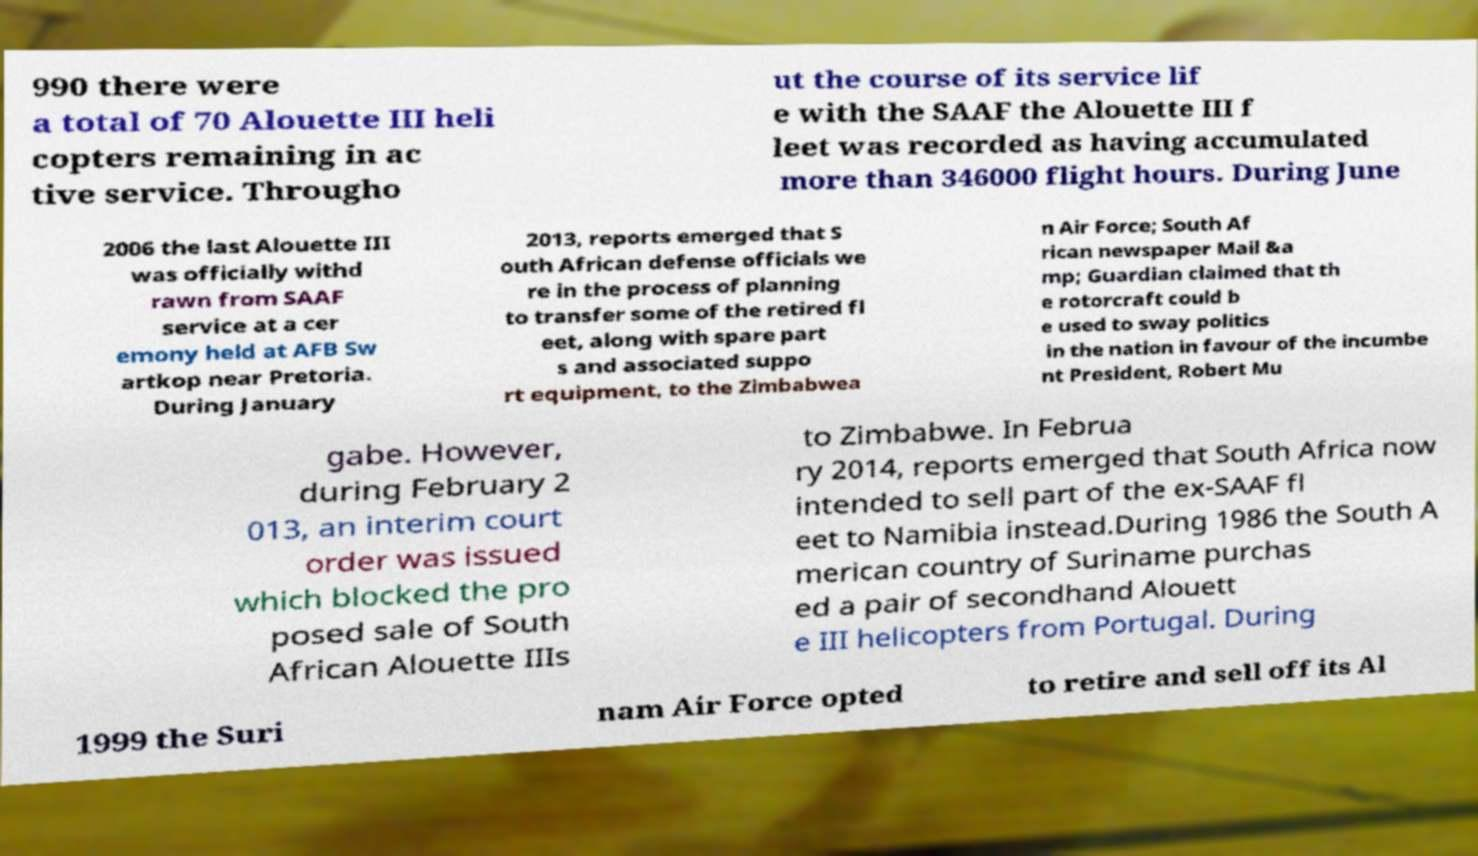What messages or text are displayed in this image? I need them in a readable, typed format. 990 there were a total of 70 Alouette III heli copters remaining in ac tive service. Througho ut the course of its service lif e with the SAAF the Alouette III f leet was recorded as having accumulated more than 346000 flight hours. During June 2006 the last Alouette III was officially withd rawn from SAAF service at a cer emony held at AFB Sw artkop near Pretoria. During January 2013, reports emerged that S outh African defense officials we re in the process of planning to transfer some of the retired fl eet, along with spare part s and associated suppo rt equipment, to the Zimbabwea n Air Force; South Af rican newspaper Mail &a mp; Guardian claimed that th e rotorcraft could b e used to sway politics in the nation in favour of the incumbe nt President, Robert Mu gabe. However, during February 2 013, an interim court order was issued which blocked the pro posed sale of South African Alouette IIIs to Zimbabwe. In Februa ry 2014, reports emerged that South Africa now intended to sell part of the ex-SAAF fl eet to Namibia instead.During 1986 the South A merican country of Suriname purchas ed a pair of secondhand Alouett e III helicopters from Portugal. During 1999 the Suri nam Air Force opted to retire and sell off its Al 